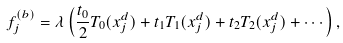Convert formula to latex. <formula><loc_0><loc_0><loc_500><loc_500>f _ { j } ^ { ( b ) } = \lambda \left ( \frac { t _ { 0 } } { 2 } T _ { 0 } ( x _ { j } ^ { d } ) + t _ { 1 } T _ { 1 } ( x _ { j } ^ { d } ) + t _ { 2 } T _ { 2 } ( x _ { j } ^ { d } ) + \cdots \right ) ,</formula> 